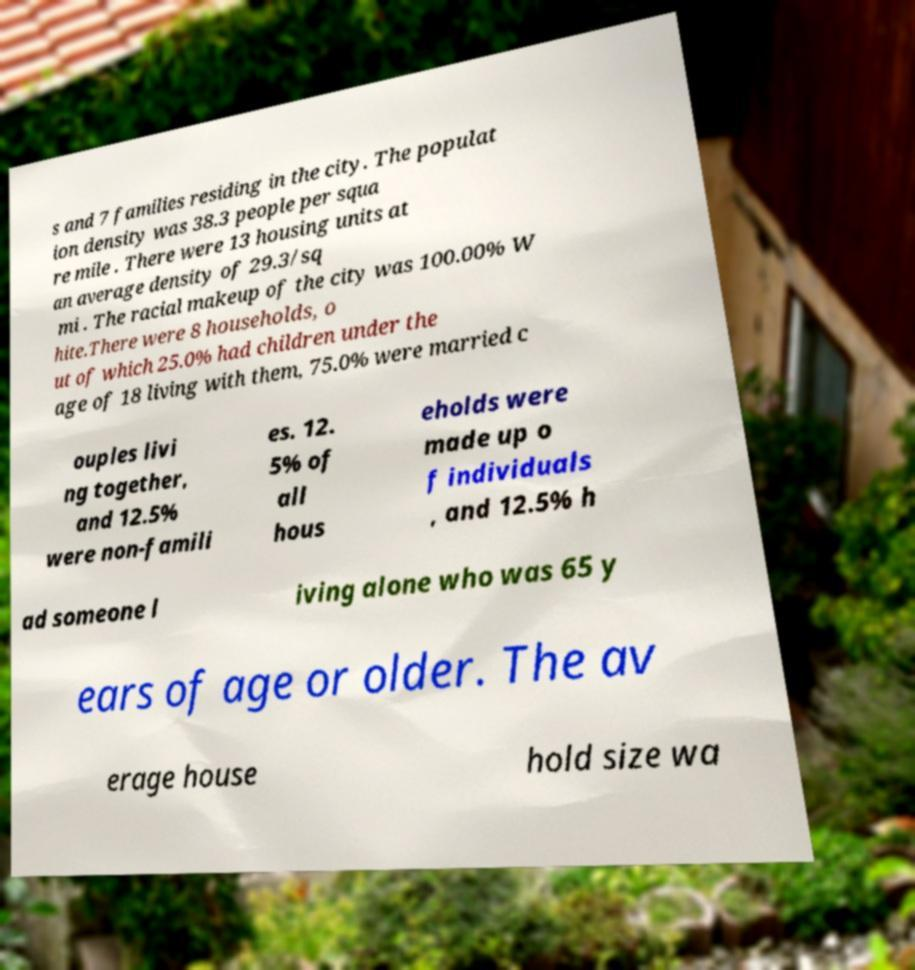What messages or text are displayed in this image? I need them in a readable, typed format. s and 7 families residing in the city. The populat ion density was 38.3 people per squa re mile . There were 13 housing units at an average density of 29.3/sq mi . The racial makeup of the city was 100.00% W hite.There were 8 households, o ut of which 25.0% had children under the age of 18 living with them, 75.0% were married c ouples livi ng together, and 12.5% were non-famili es. 12. 5% of all hous eholds were made up o f individuals , and 12.5% h ad someone l iving alone who was 65 y ears of age or older. The av erage house hold size wa 